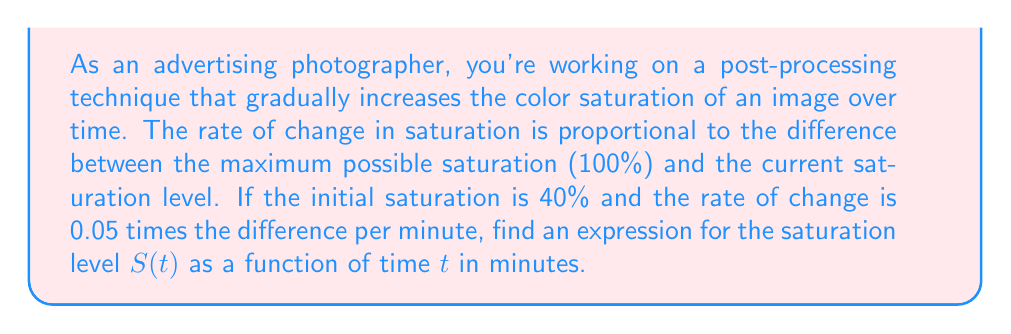Teach me how to tackle this problem. Let's approach this step-by-step:

1) First, we need to set up our differential equation. Let $S(t)$ be the saturation level at time $t$. The maximum saturation is 100% or 1 in decimal form.

2) The rate of change in saturation is proportional to the difference between the maximum saturation and the current saturation:

   $$\frac{dS}{dt} = k(1 - S)$$

   where $k = 0.05$ per minute.

3) This is a separable first-order differential equation. We can solve it by separating variables:

   $$\frac{dS}{1-S} = 0.05 dt$$

4) Integrating both sides:

   $$\int \frac{dS}{1-S} = \int 0.05 dt$$

   $$-\ln|1-S| = 0.05t + C$$

5) Solving for $S$:

   $$1-S = e^{-(0.05t + C)}$$
   $$S = 1 - Ae^{-0.05t}$$

   where $A = e^{-C}$ is a constant we need to determine.

6) We're given the initial condition: when $t=0$, $S=0.4$. Let's use this:

   $$0.4 = 1 - A$$
   $$A = 0.6$$

7) Therefore, our final expression for $S(t)$ is:

   $$S(t) = 1 - 0.6e^{-0.05t}$$

This expression gives the saturation level at any time $t$ in minutes.
Answer: $$S(t) = 1 - 0.6e^{-0.05t}$$ 